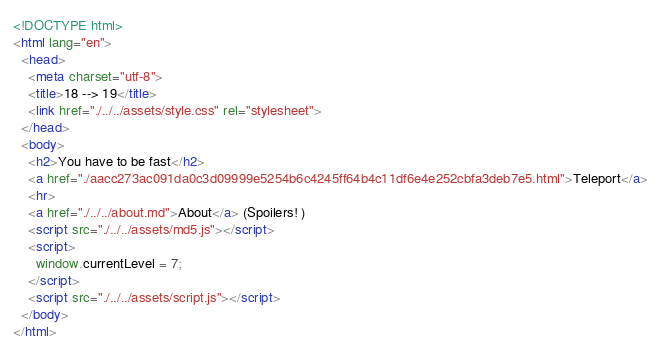Convert code to text. <code><loc_0><loc_0><loc_500><loc_500><_HTML_><!DOCTYPE html>
<html lang="en">
  <head>
    <meta charset="utf-8">
    <title>18 --> 19</title>
    <link href="./../../assets/style.css" rel="stylesheet">
  </head>
  <body>
    <h2>You have to be fast</h2>
    <a href="./aacc273ac091da0c3d09999e5254b6c4245ff64b4c11df6e4e252cbfa3deb7e5.html">Teleport</a>
    <hr>
    <a href="./../../about.md">About</a> (Spoilers! )
    <script src="./../../assets/md5.js"></script>
    <script>
      window.currentLevel = 7;
    </script>
    <script src="./../../assets/script.js"></script>
  </body>
</html></code> 